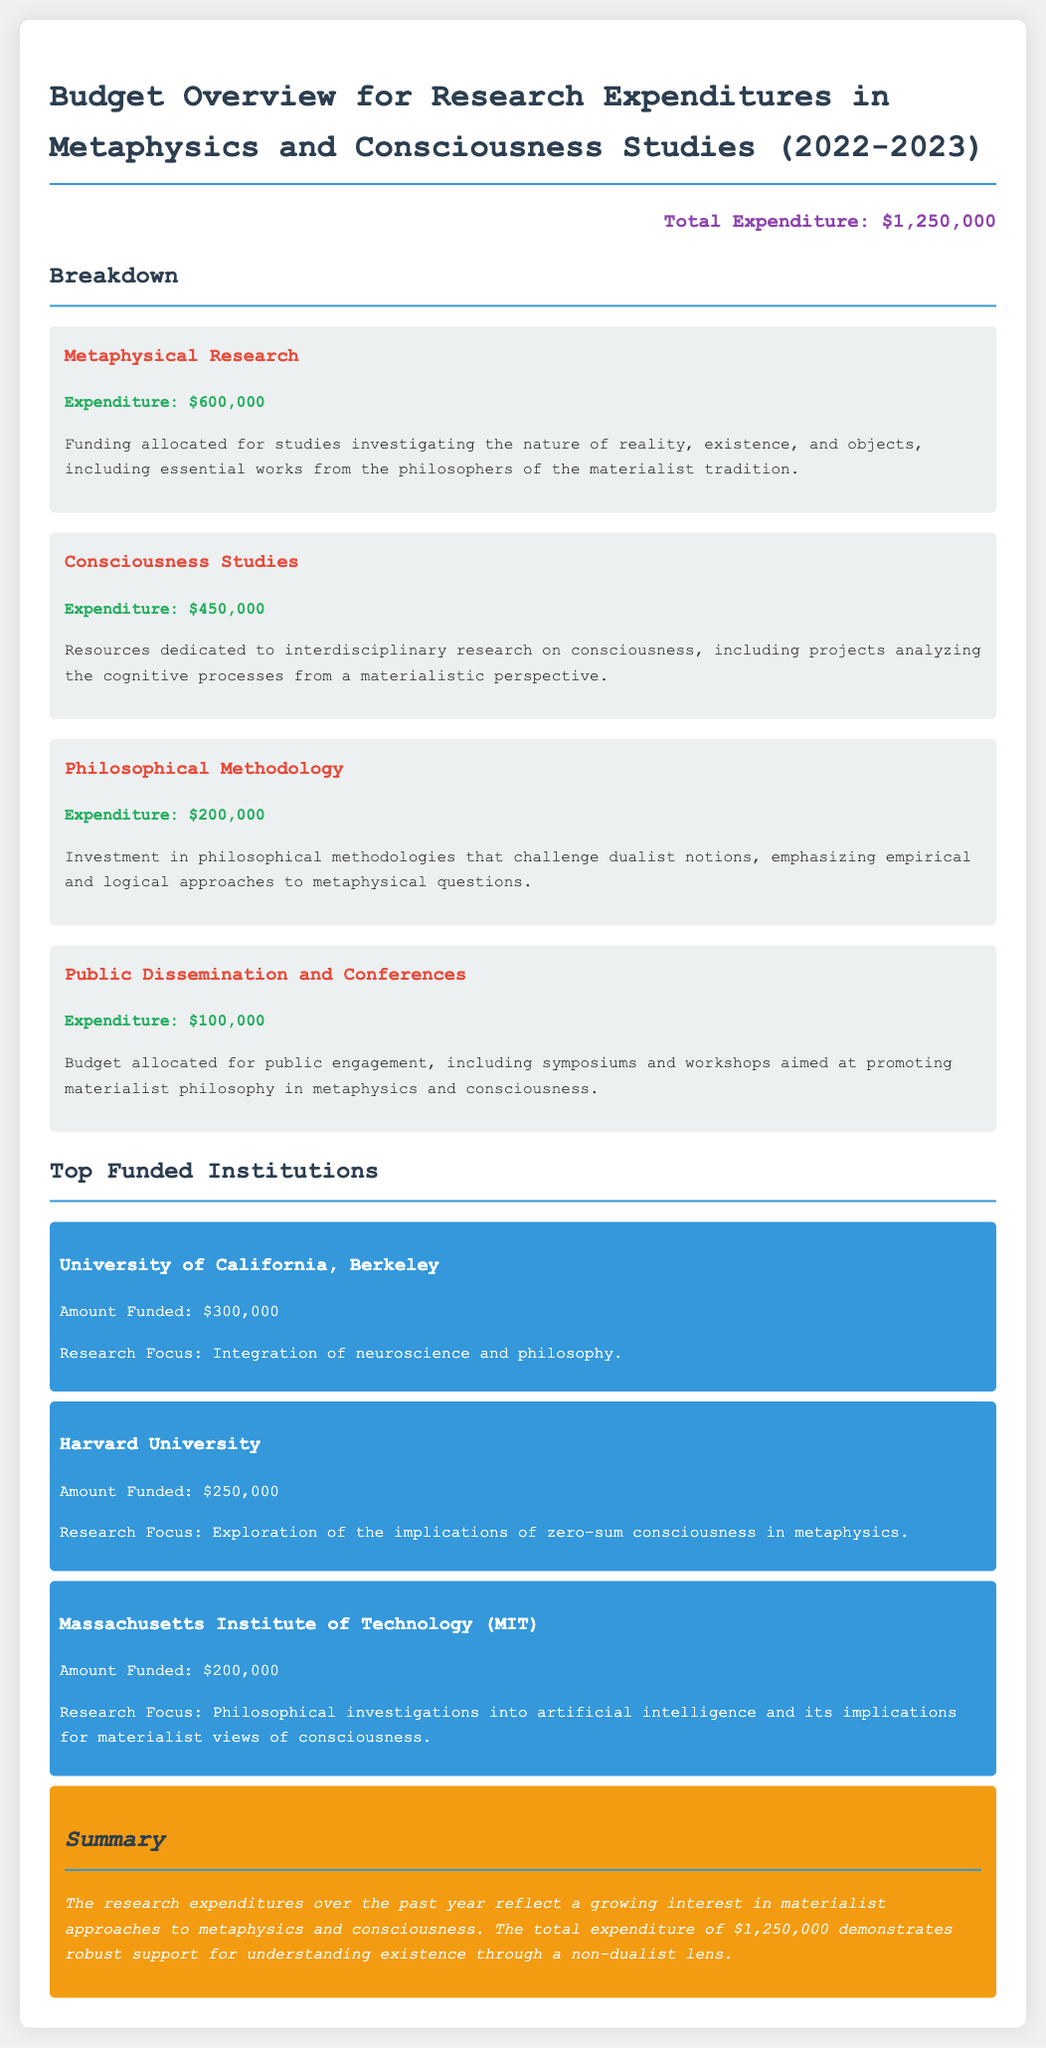What is the total expenditure? The total expenditure is listed prominently at the beginning of the budget overview section, amounting to $1,250,000.
Answer: $1,250,000 How much was spent on Metaphysical Research? The budget overview contains a breakdown of expenses, specifically stating the expenditure for Metaphysical Research as $600,000.
Answer: $600,000 What institution received the highest funding? The document lists topped funded institutions in order, with the University of California, Berkeley receiving the most at $300,000.
Answer: University of California, Berkeley What was the expenditure for Public Dissemination and Conferences? In the budget overview, the specific section on Public Dissemination and Conferences indicates an expenditure of $100,000.
Answer: $100,000 What is the research focus of Harvard University? Each institution’s funding section includes a brief description, with Harvard’s focus being the exploration of zero-sum consciousness in metaphysics.
Answer: Exploration of the implications of zero-sum consciousness in metaphysics How much funding did MIT receive? The budget overview provides funding amounts for various institutions, specifically stating that MIT received $200,000.
Answer: $200,000 What type of philosophical methodologies were funded? The document mentions funding invested in philosophical methodologies that challenge dualist notions and emphasize empirical and logical approaches.
Answer: Philosophical methodologies that challenge dualist notions What is the total funding for Consciousness Studies? The Consciousness Studies expense is detailed in the budget section, showing an expenditure of $450,000.
Answer: $450,000 